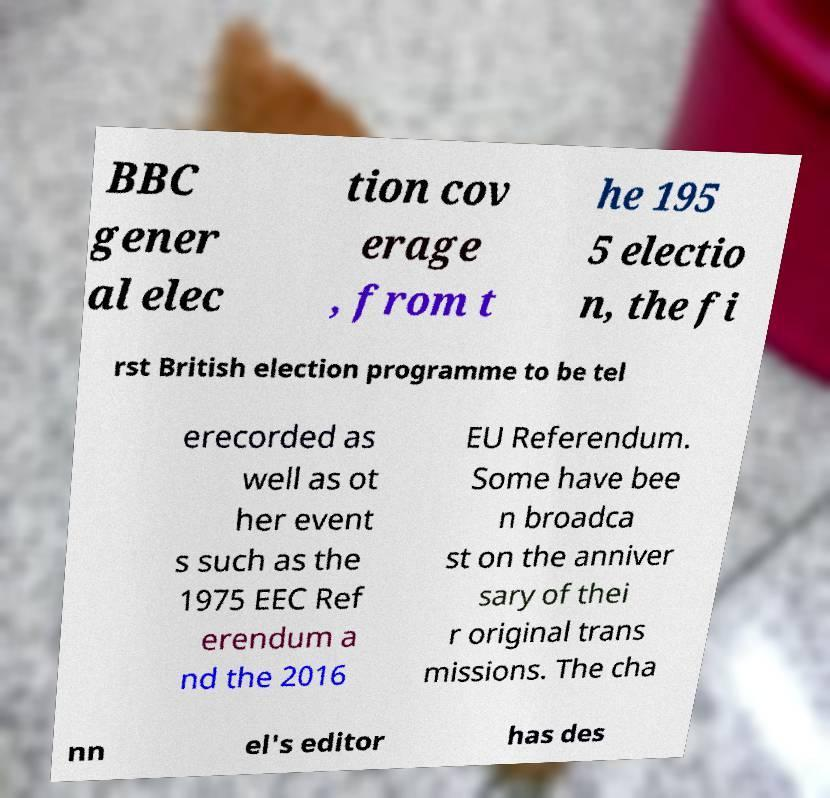For documentation purposes, I need the text within this image transcribed. Could you provide that? BBC gener al elec tion cov erage , from t he 195 5 electio n, the fi rst British election programme to be tel erecorded as well as ot her event s such as the 1975 EEC Ref erendum a nd the 2016 EU Referendum. Some have bee n broadca st on the anniver sary of thei r original trans missions. The cha nn el's editor has des 